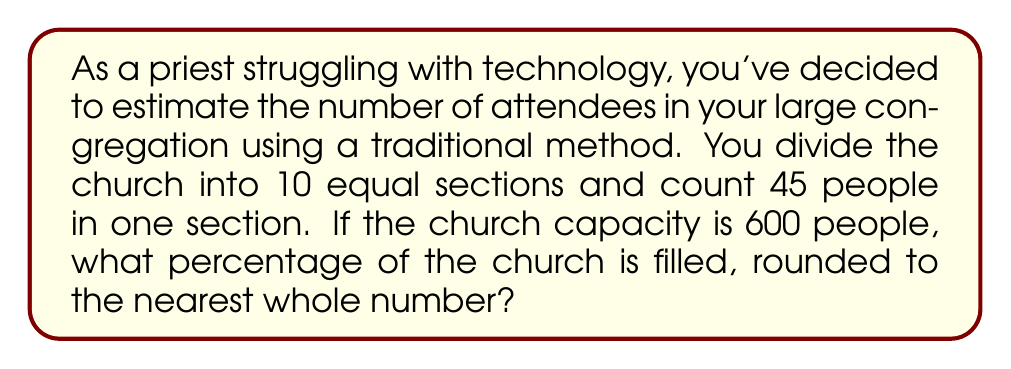Teach me how to tackle this problem. Let's approach this problem step-by-step:

1) First, we need to estimate the total number of attendees. Since we counted 45 people in one section, and there are 10 equal sections, we can multiply:

   $$ \text{Estimated attendees} = 45 \times 10 = 450 $$

2) Now, we need to calculate what percentage 450 is of the total capacity (600). We can use the formula:

   $$ \text{Percentage} = \frac{\text{Part}}{\text{Whole}} \times 100\% $$

3) Plugging in our numbers:

   $$ \text{Percentage} = \frac{450}{600} \times 100\% $$

4) Simplifying the fraction:

   $$ \text{Percentage} = \frac{3}{4} \times 100\% = 75\% $$

5) The question asks for the answer rounded to the nearest whole number. 75% is already a whole number, so no further rounding is necessary.

This method, while simple, provides a reasonable estimate without relying on modern technology, fitting well with the traditional approach of the priest.
Answer: 75% 